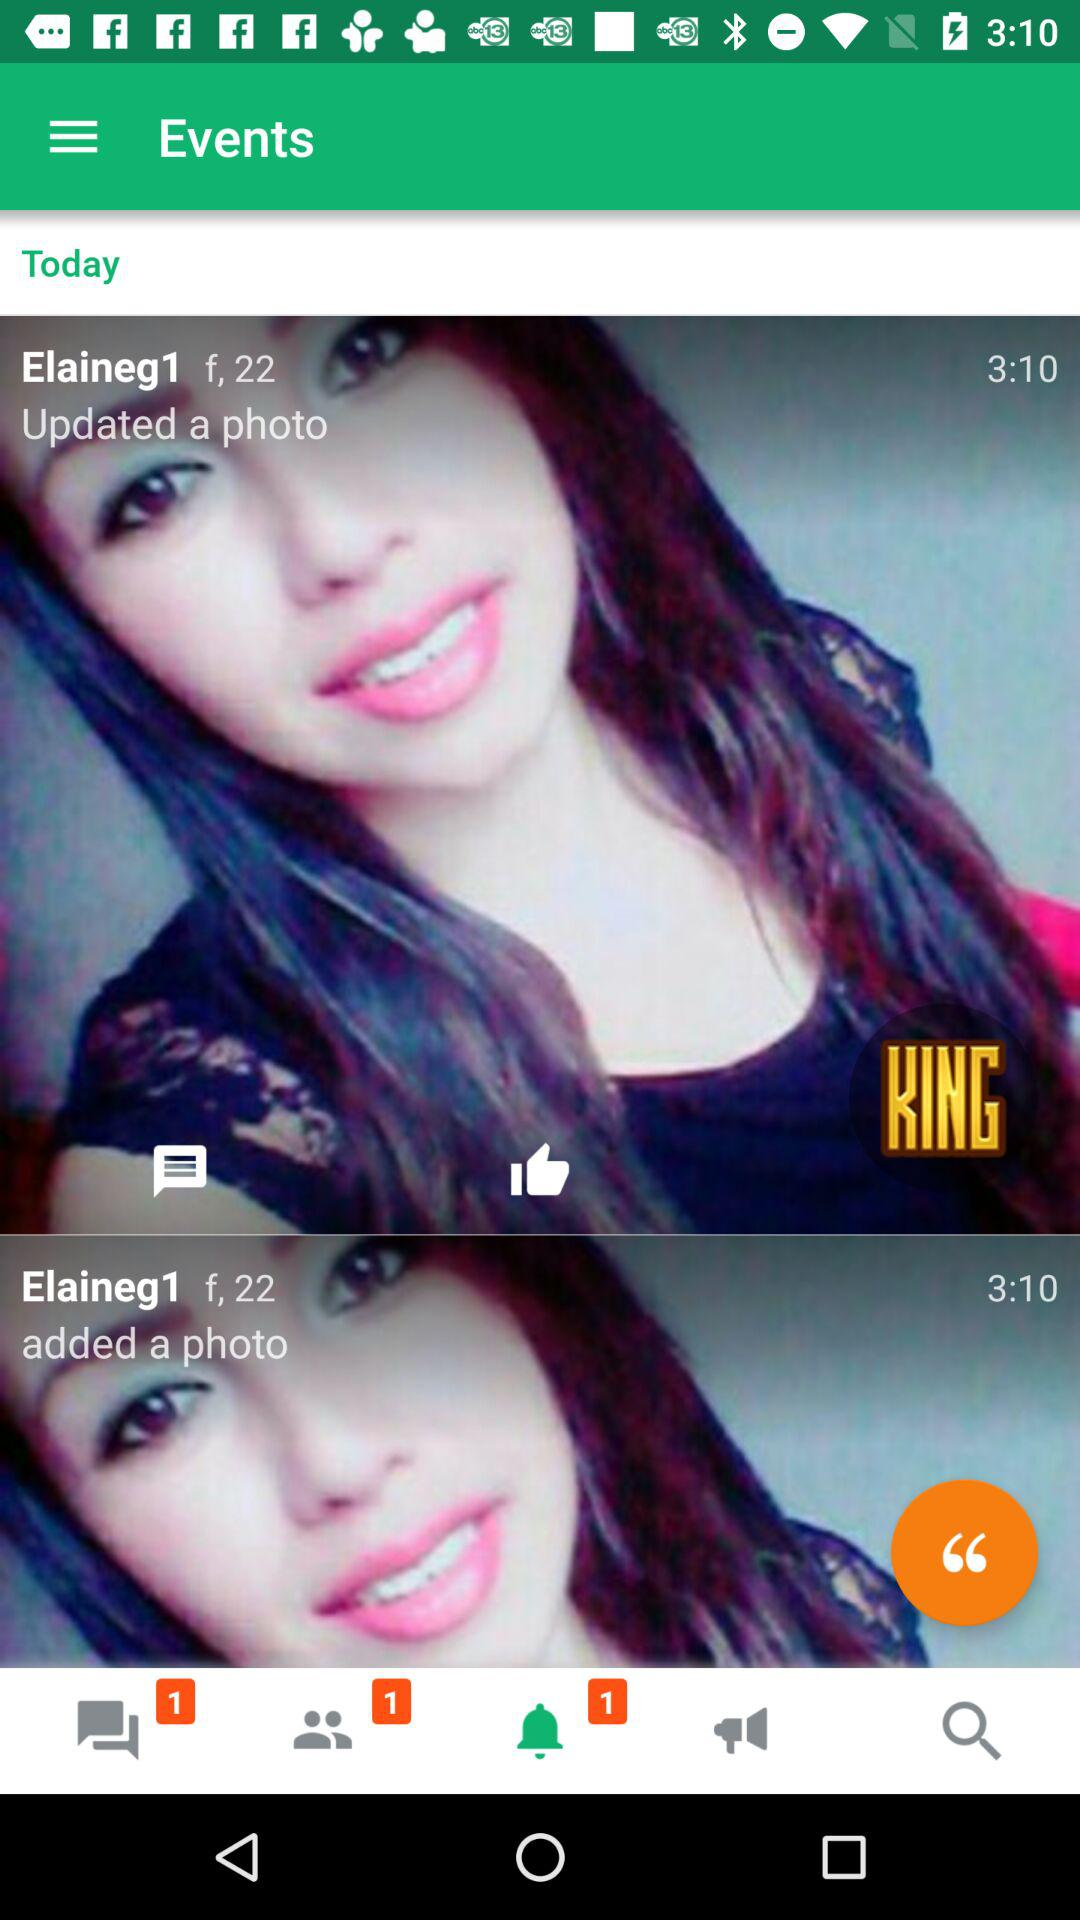At what time did Elaineg1 update a photo? The photo was updated at 3:10. 